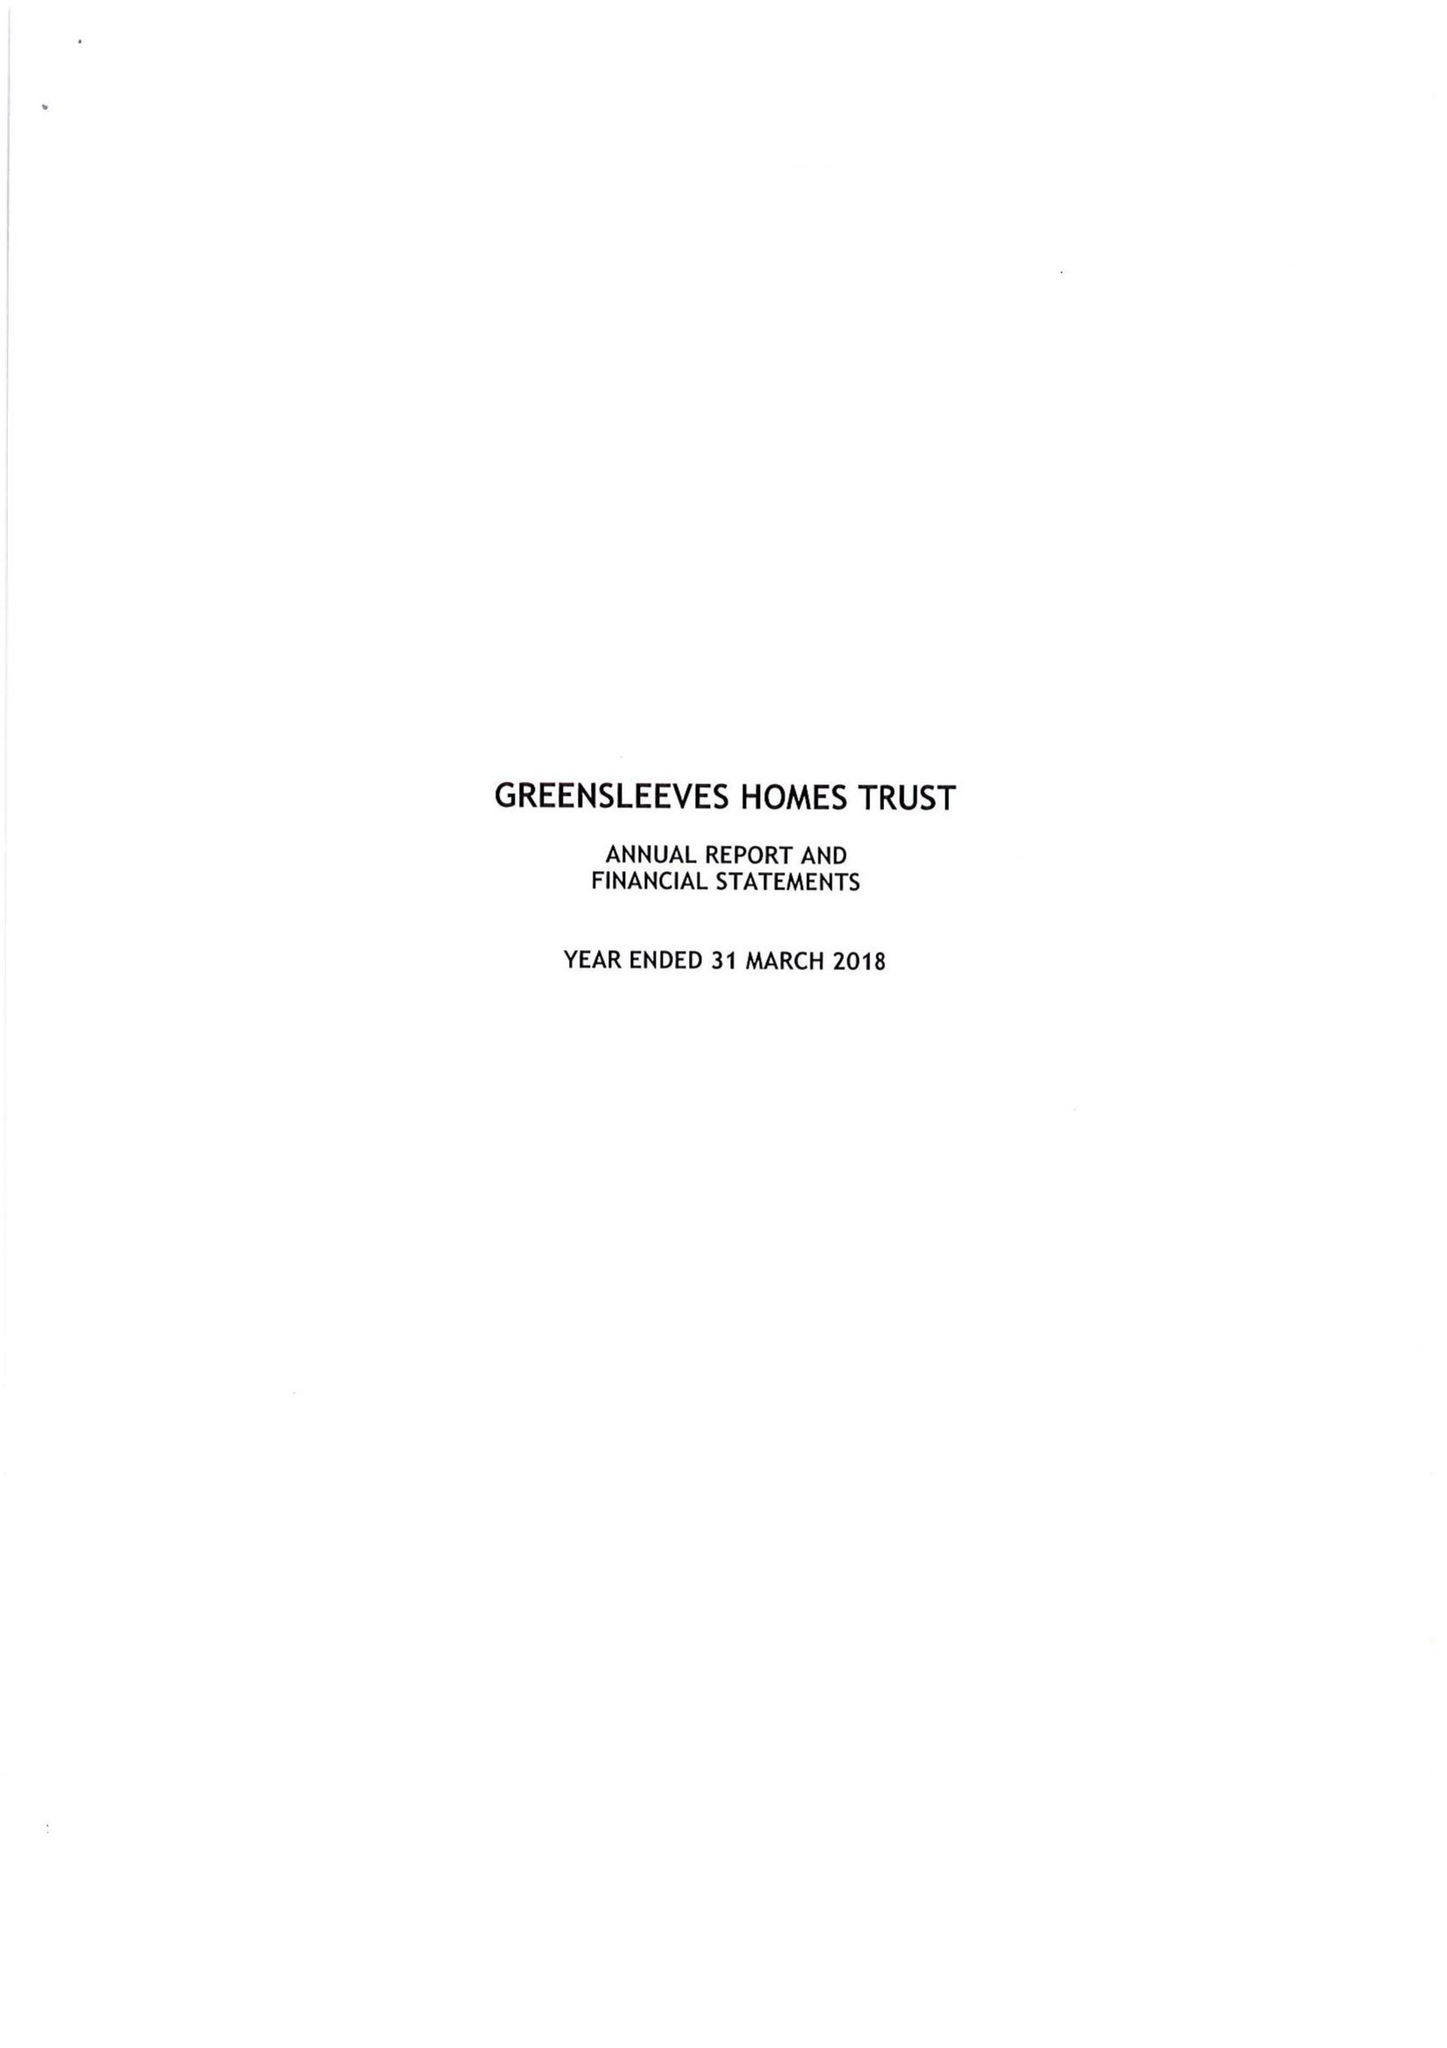What is the value for the income_annually_in_british_pounds?
Answer the question using a single word or phrase. 34645577.00 